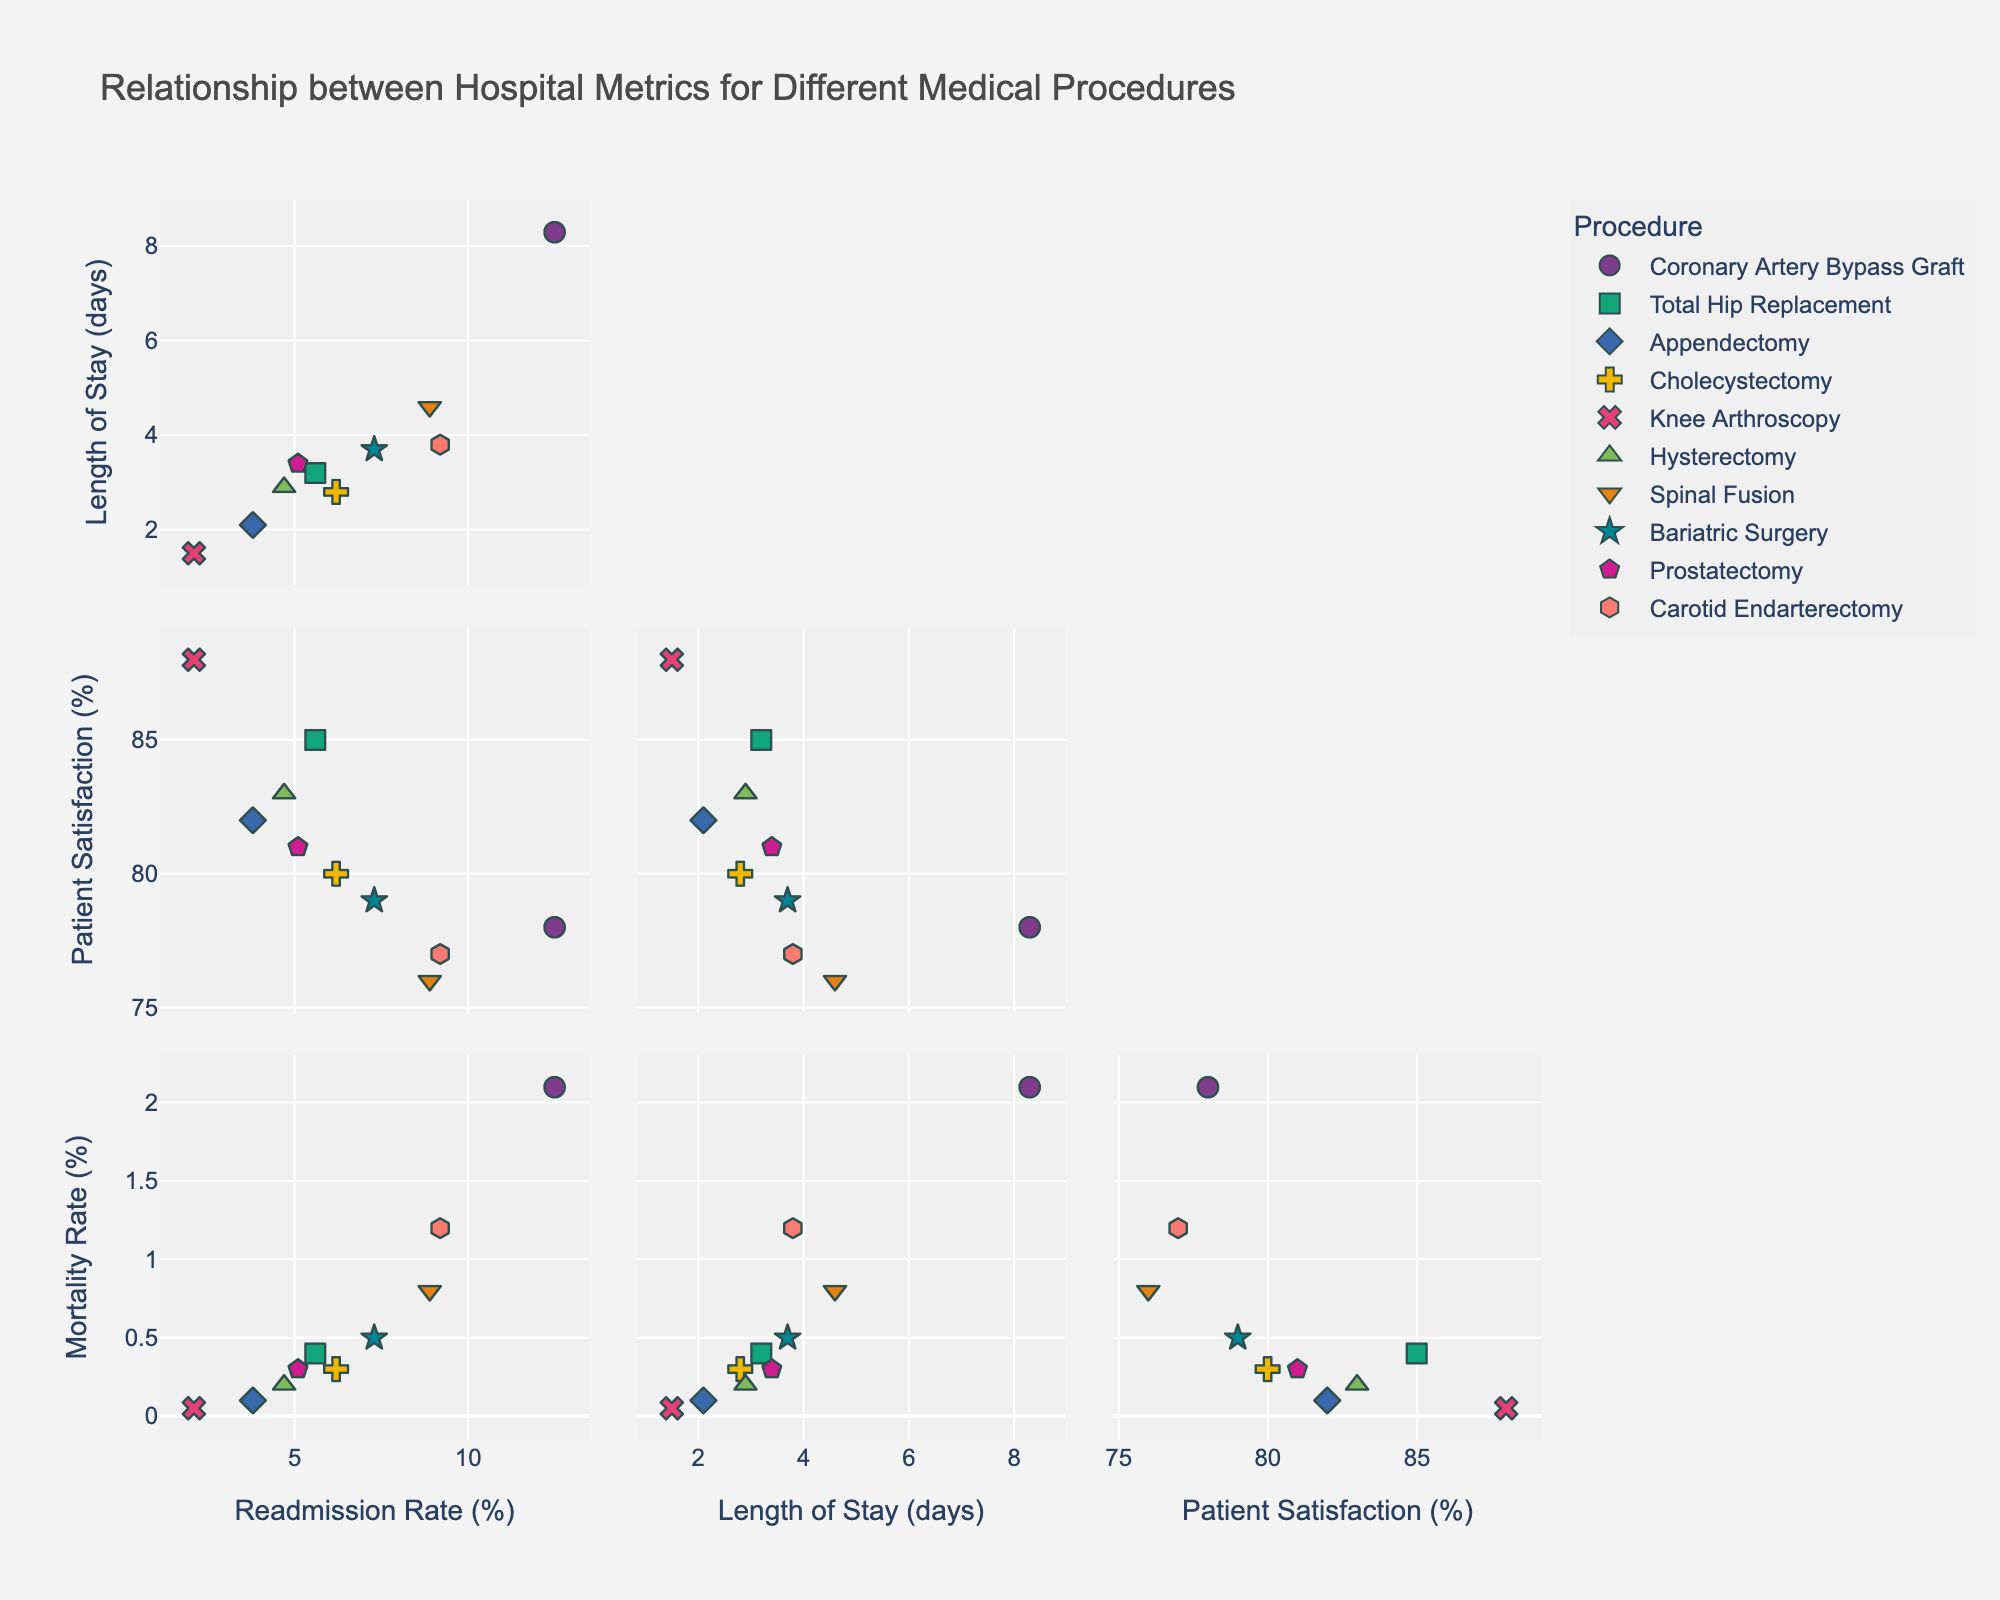What is the title of the scatterplot matrix? The title is located at the top of the figure and clearly states the purpose of the scatterplot matrix.
Answer: Relationship between Hospital Metrics for Different Medical Procedures Which medical procedure has the lowest readmission rate? To determine this, check the 'Readmission Rate' axis and identify the procedure with the smallest corresponding value.
Answer: Knee Arthroscopy What is the average length of stay across all procedures? Sum the 'Length of Stay' for all procedures and divide by the number of procedures (10). Calculation: (8.3 + 3.2 + 2.1 + 2.8 + 1.5 + 2.9 + 4.6 + 3.7 + 3.4 + 3.8) / 10 = 3.63 days
Answer: 3.63 days How many data points are displayed in the scatterplot matrix? Each procedure represents a unique data point. Since there are 10 procedures listed, the scatterplot matrix contains 10 data points.
Answer: 10 Which procedure has the highest patient satisfaction rate? Check the 'Patient Satisfaction' axis and identify the procedure with the highest corresponding value.
Answer: Knee Arthroscopy Compare readmission rates: Which procedure has a higher readmission rate, Coronary Artery Bypass Graft or Carotid Endarterectomy? Locate the 'Readmission Rate' for both procedures and compare their values: Coronary Artery Bypass Graft (12.5%) vs. Carotid Endarterectomy (9.2%).
Answer: Coronary Artery Bypass Graft What is the difference in mortality rate between Total Hip Replacement and Spinal Fusion? Subtract the 'Mortality Rate' of Total Hip Replacement (0.4%) from Spinal Fusion (0.8%) to find the difference: 0.8% - 0.4% = 0.4%.
Answer: 0.4% For which medical procedures do readmission rates exceed 5%? Identify procedures with a 'Readmission Rate' greater than 5%.
Answer: Coronary Artery Bypass Graft, Total Hip Replacement, Cholecystectomy, Spinal Fusion, Bariatric Surgery, Carotid Endarterectomy Is there any correlation between Length of Stay and Patient Satisfaction? By visually inspecting the scatterplot, look at the plot that compares 'Length of Stay' vs. 'Patient Satisfaction' for a trend or pattern.
Answer: No clear correlation 